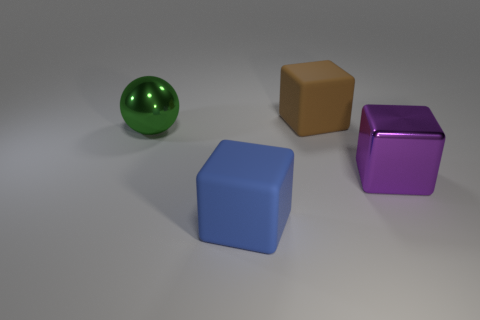How many large blue cubes are made of the same material as the large purple block?
Your answer should be very brief. 0. Are there an equal number of large green shiny spheres in front of the big green sphere and big green matte cylinders?
Give a very brief answer. Yes. There is a matte object that is behind the large blue matte thing; what is its size?
Give a very brief answer. Large. What number of large things are either rubber cubes or cyan metallic cubes?
Offer a very short reply. 2. There is another matte object that is the same shape as the large blue object; what color is it?
Your response must be concise. Brown. Do the purple metal cube and the brown rubber object have the same size?
Provide a short and direct response. Yes. How many objects are large purple cylinders or matte cubes in front of the green shiny thing?
Your response must be concise. 1. There is a rubber thing in front of the large rubber object that is right of the large blue object; what is its color?
Your answer should be compact. Blue. There is a big green sphere left of the blue rubber thing; what is its material?
Offer a terse response. Metal. How big is the metal cube?
Give a very brief answer. Large. 